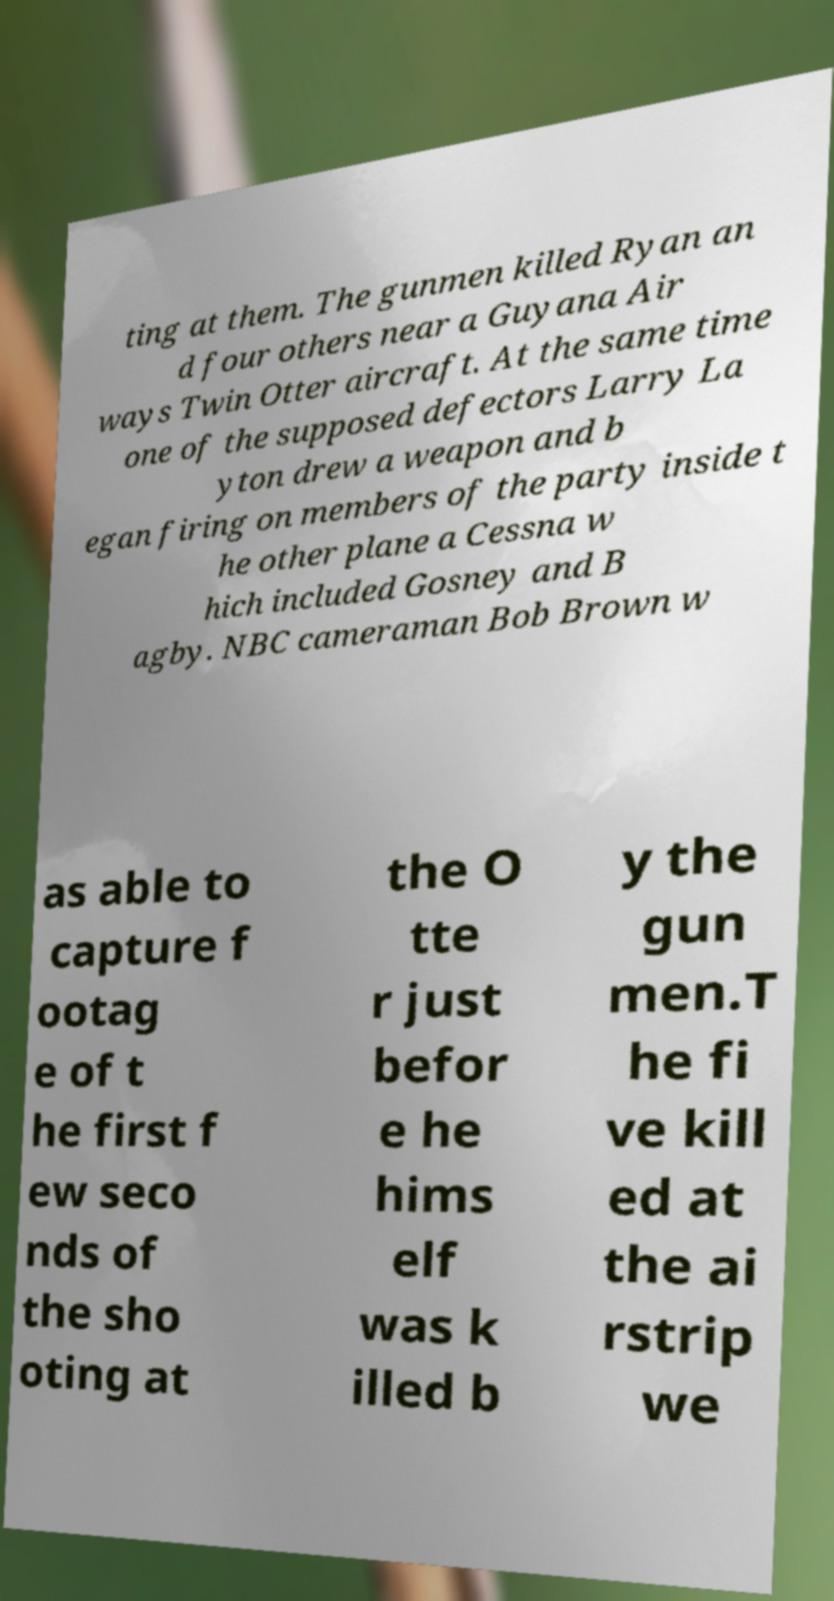Please identify and transcribe the text found in this image. ting at them. The gunmen killed Ryan an d four others near a Guyana Air ways Twin Otter aircraft. At the same time one of the supposed defectors Larry La yton drew a weapon and b egan firing on members of the party inside t he other plane a Cessna w hich included Gosney and B agby. NBC cameraman Bob Brown w as able to capture f ootag e of t he first f ew seco nds of the sho oting at the O tte r just befor e he hims elf was k illed b y the gun men.T he fi ve kill ed at the ai rstrip we 